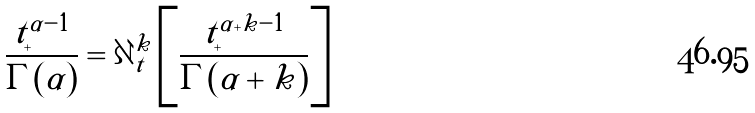<formula> <loc_0><loc_0><loc_500><loc_500>\frac { t _ { + } ^ { \alpha - 1 } } { \Gamma ( \alpha ) } = \partial _ { t } ^ { k } \left [ \frac { t _ { + } ^ { \alpha + k - 1 } } { \Gamma ( \alpha + k ) } \right ]</formula> 